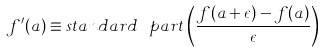<formula> <loc_0><loc_0><loc_500><loc_500>f ^ { \prime } ( a ) \equiv s t a n d a r d \text { } p a r t \left ( \frac { f ( a + \epsilon ) - f ( a ) } { \epsilon } \right )</formula> 